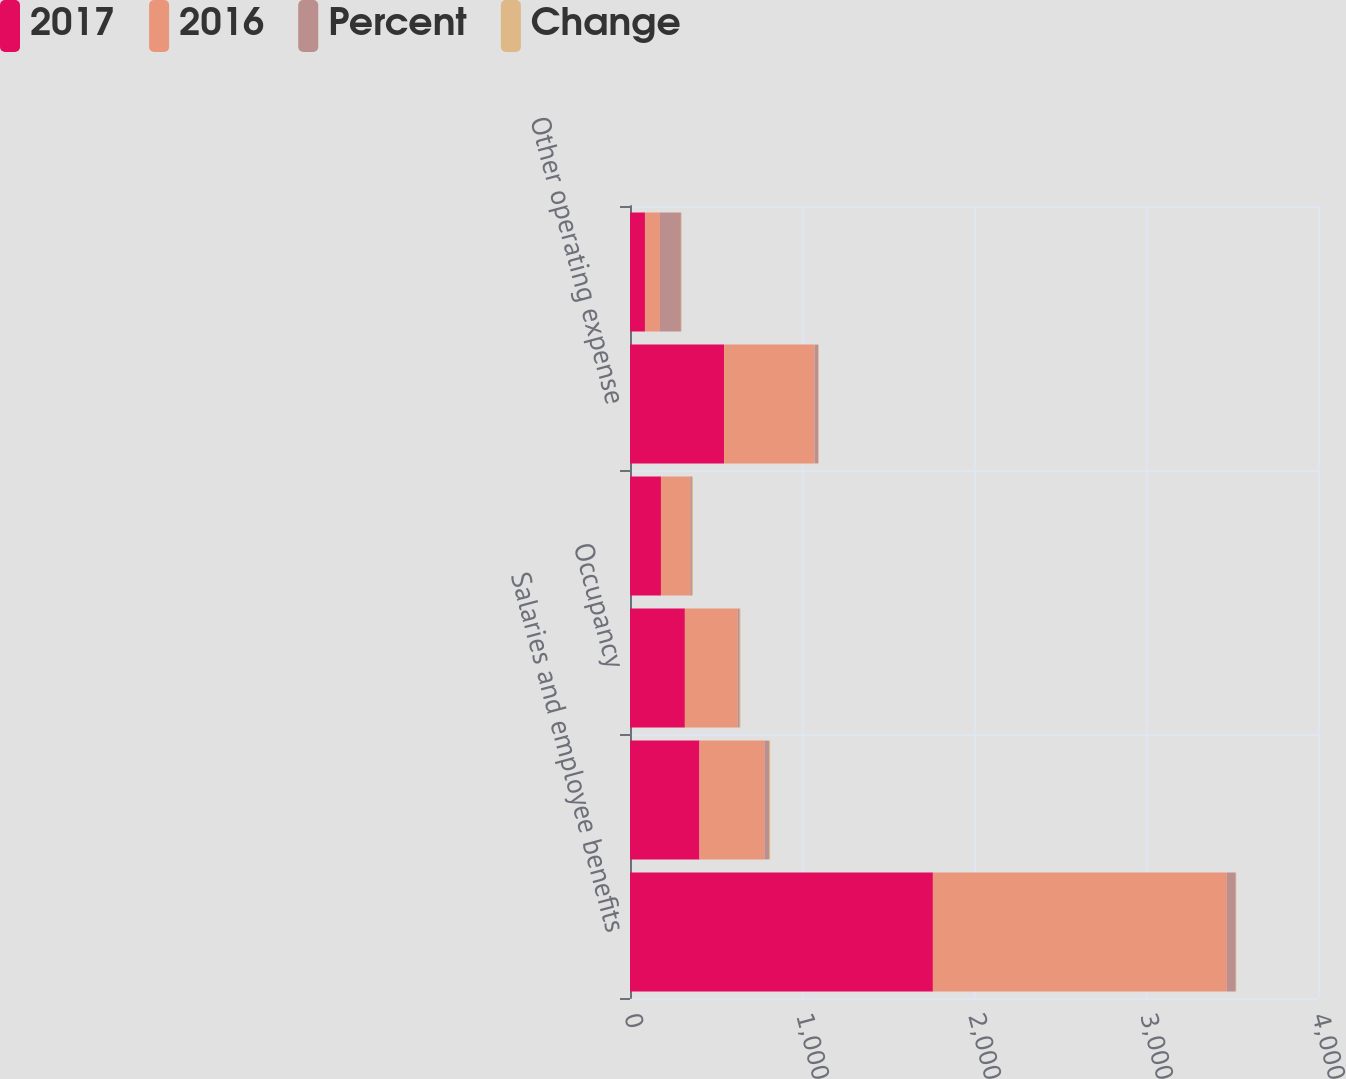Convert chart. <chart><loc_0><loc_0><loc_500><loc_500><stacked_bar_chart><ecel><fcel>Salaries and employee benefits<fcel>Outside services<fcel>Occupancy<fcel>Amortization of software<fcel>Other operating expense<fcel>Noninterest expense<nl><fcel>2017<fcel>1761<fcel>404<fcel>319<fcel>180<fcel>547<fcel>87<nl><fcel>2016<fcel>1709<fcel>377<fcel>307<fcel>170<fcel>526<fcel>87<nl><fcel>Percent<fcel>52<fcel>27<fcel>12<fcel>10<fcel>21<fcel>122<nl><fcel>Change<fcel>3<fcel>7<fcel>4<fcel>6<fcel>4<fcel>4<nl></chart> 